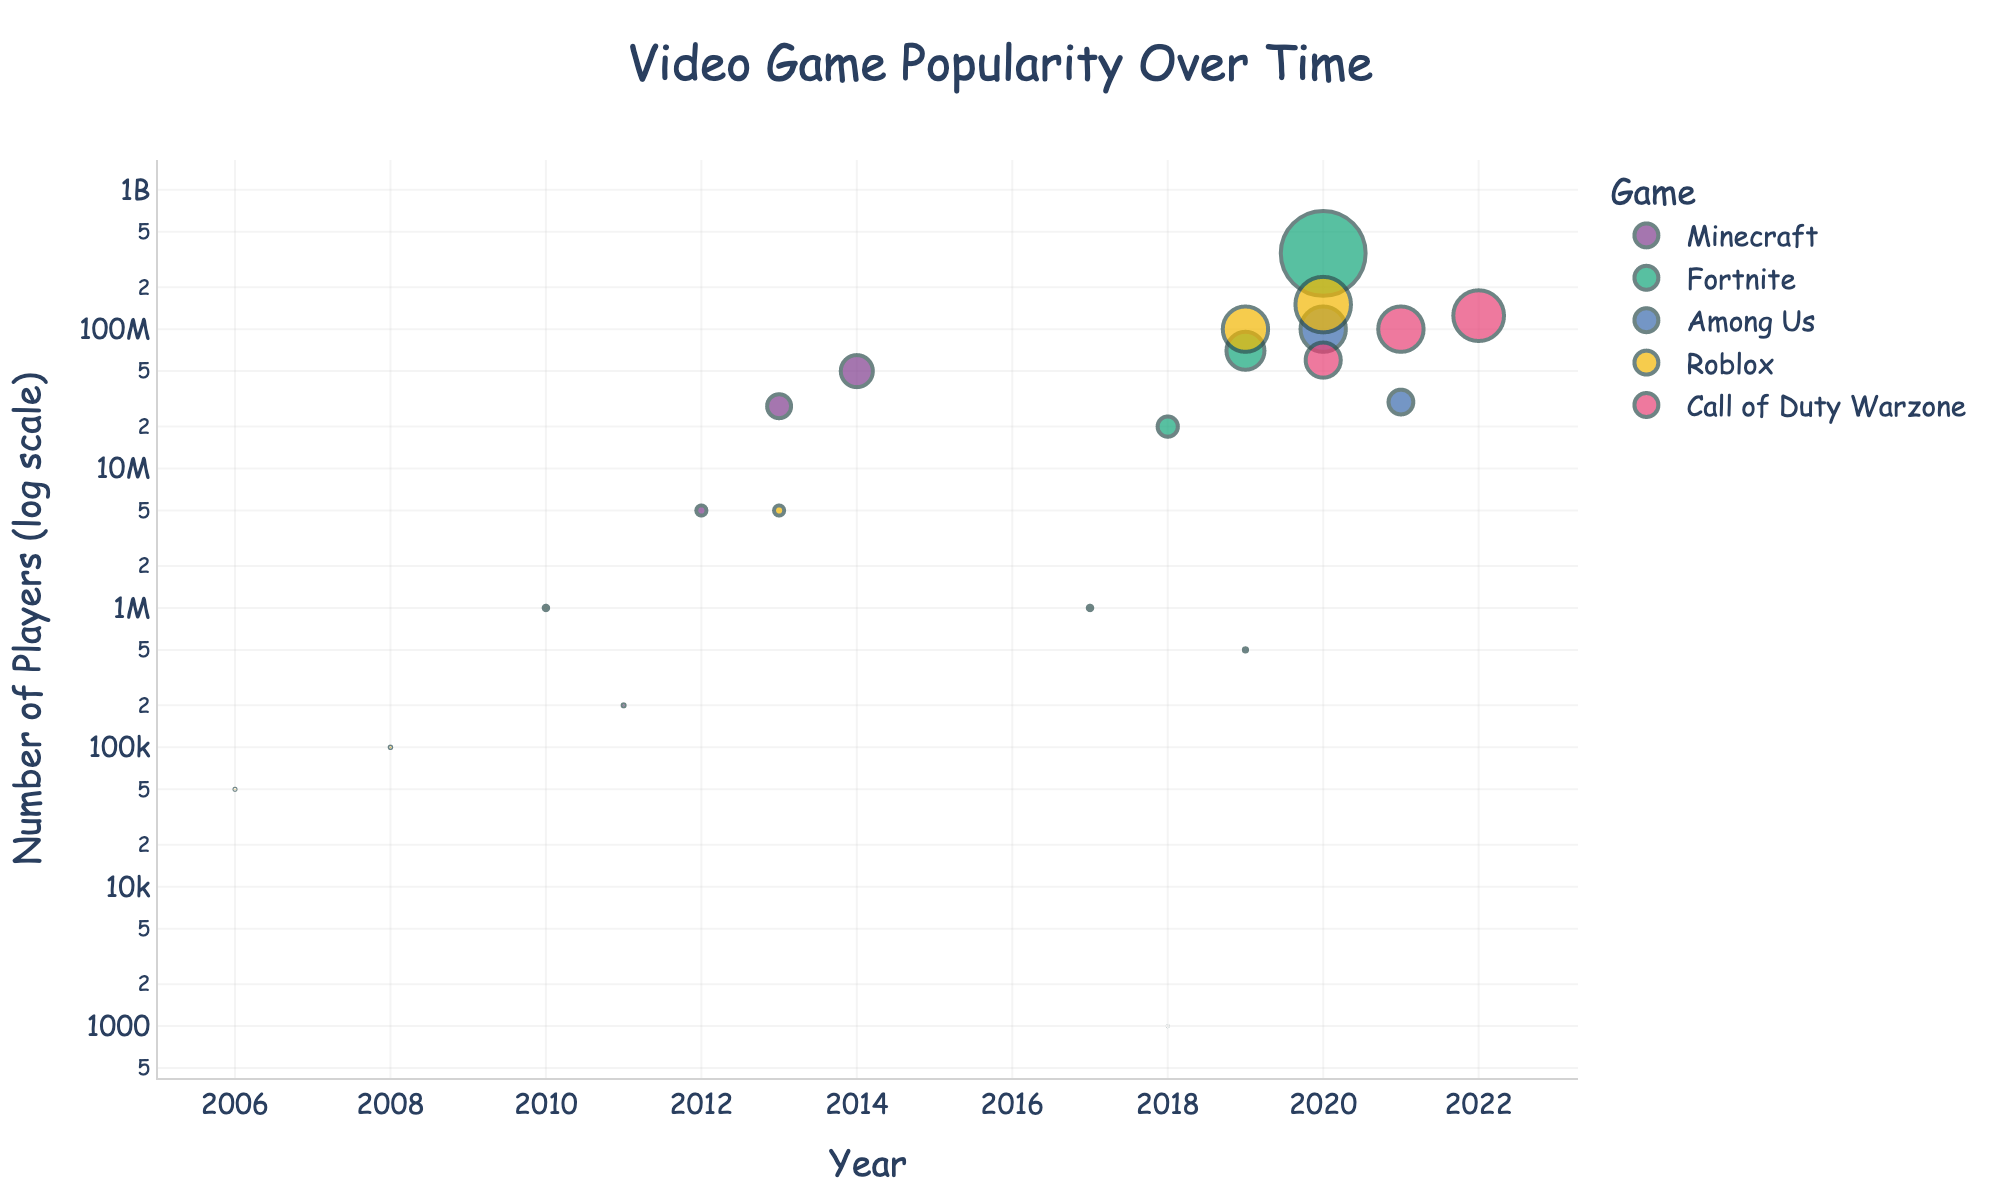What is the title of the scatter plot? The title of the scatter plot is usually displayed at the top of the figure in large font. It summarizes the overall content of the plot.
Answer: Video Game Popularity Over Time Which game had the highest number of players in 2020? Look for the year 2020 on the x-axis and then find the data point with the highest y-value for that year. Check the color and label associated with this point.
Answer: Fortnite How many data points are there for Roblox? Identify all points on the scatter plot that are associated with Roblox by color or hover data, and count them.
Answer: 5 Which game showed the first appearance in the figure and in which year? Look for the earliest year on the x-axis and identify which game corresponds to that point.
Answer: Roblox, 2006 How many games have more than one data point? Count all the different games that appear with two or more data points in the scatter plot.
Answer: 5 Which game had the largest increase in players from one year to the next? Compare the increase in the y-values (number of players) between consecutive years for all games and identify the largest jump.
Answer: Fortnite In which year did Among Us reach its peak number of players? Find the data points for Among Us and determine which year corresponds to the highest y-value (number of players).
Answer: 2020 How does the popularity of Call of Duty Warzone change over the years? Look at the trend of data points for Call of Duty Warzone, starting from the first appearance to the last appearance.
Answer: Increasing What is the range of years covered in the plot? Identify the earliest and the latest year on the x-axis to determine the span of years included in the plot.
Answer: 2006-2022 Compare the number of players of Roblox in 2013 and Fortnite in 2018. Which one had more players? Look for the y-values (number of players) for Roblox in 2013 and compare it with Fortnite in 2018 to determine which is greater.
Answer: Fortnite 